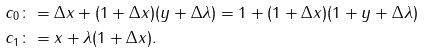<formula> <loc_0><loc_0><loc_500><loc_500>c _ { 0 } & \colon = \Delta x + ( 1 + \Delta x ) ( y + \Delta \lambda ) = 1 + ( 1 + \Delta x ) ( 1 + y + \Delta \lambda ) \\ c _ { 1 } & \colon = x + \lambda ( 1 + \Delta x ) .</formula> 